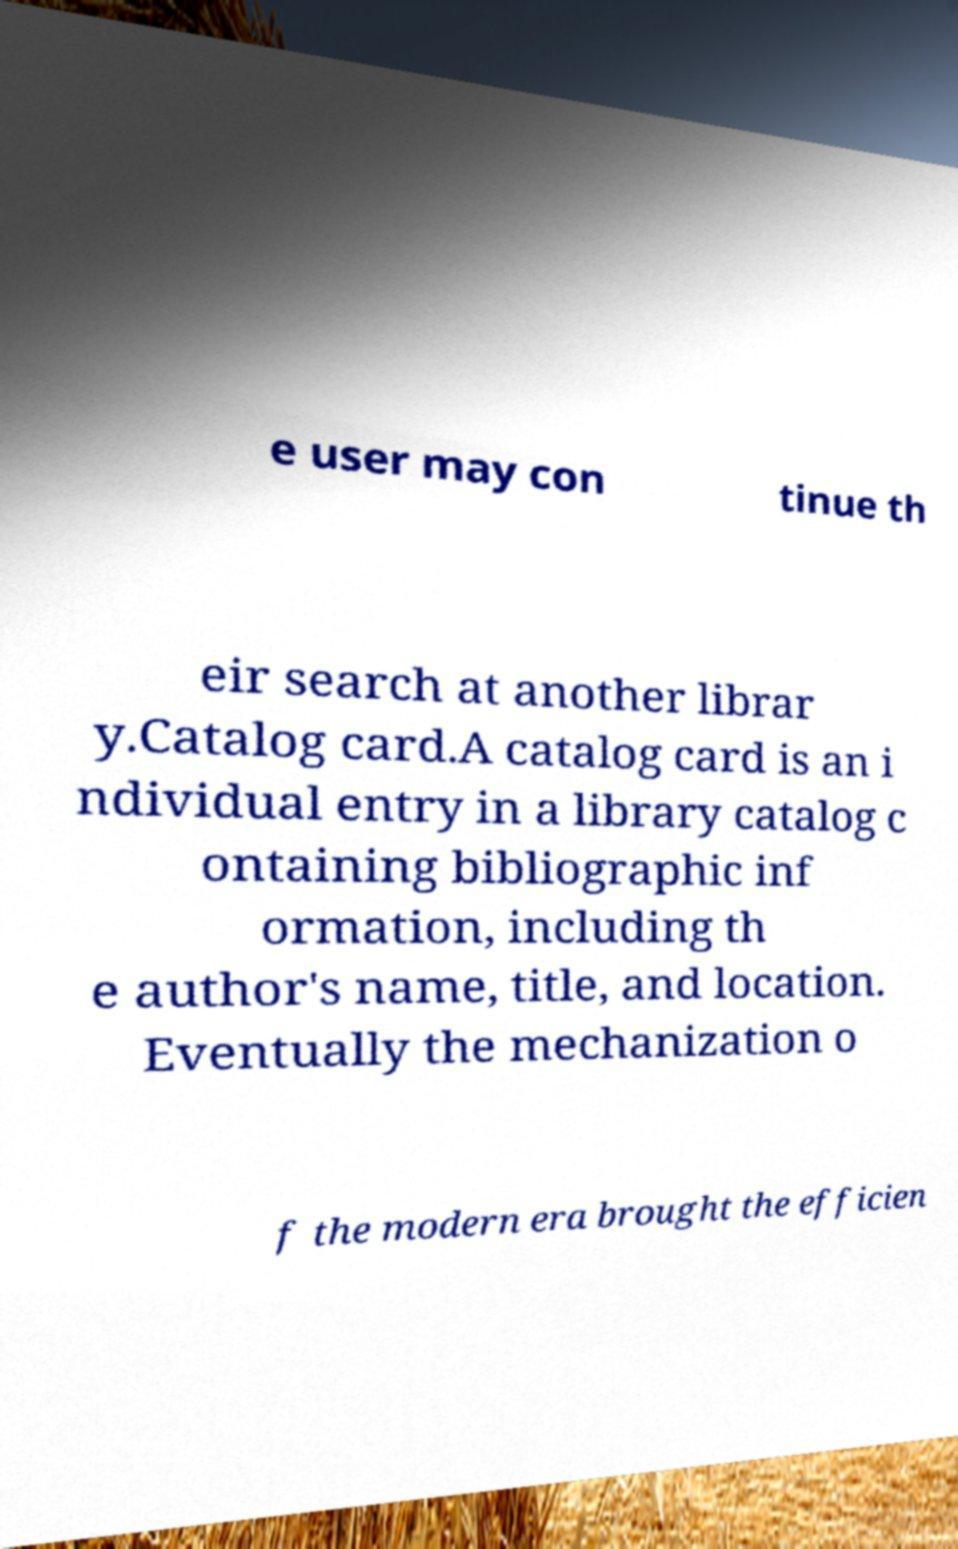I need the written content from this picture converted into text. Can you do that? e user may con tinue th eir search at another librar y.Catalog card.A catalog card is an i ndividual entry in a library catalog c ontaining bibliographic inf ormation, including th e author's name, title, and location. Eventually the mechanization o f the modern era brought the efficien 